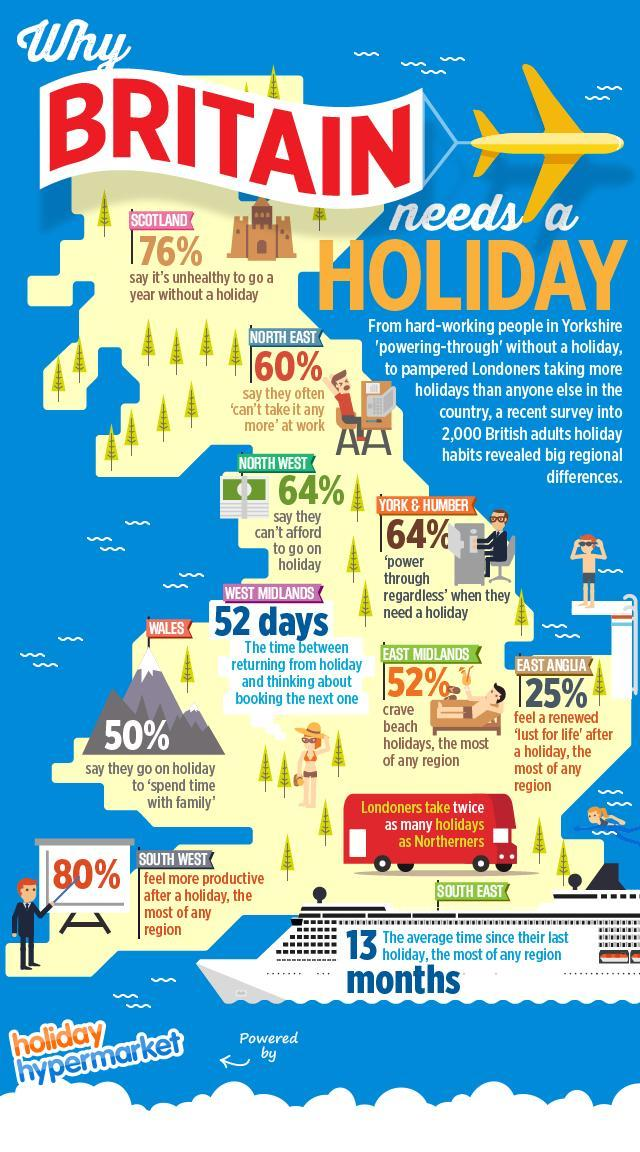Where do 52% crave for beach holidays the most
Answer the question with a short phrase. East Midlands Why do 50% from wales go on holiday to 'spend time with family' What % in North West can afford to go on a holiday 36 What is the colour of the aeroplane, yellow or white yellow Within how many months of returning from a holiday do West Midlands plan the next holiday 2 If a Northerner would take 2 holidays, how much would a Londoner take 4 